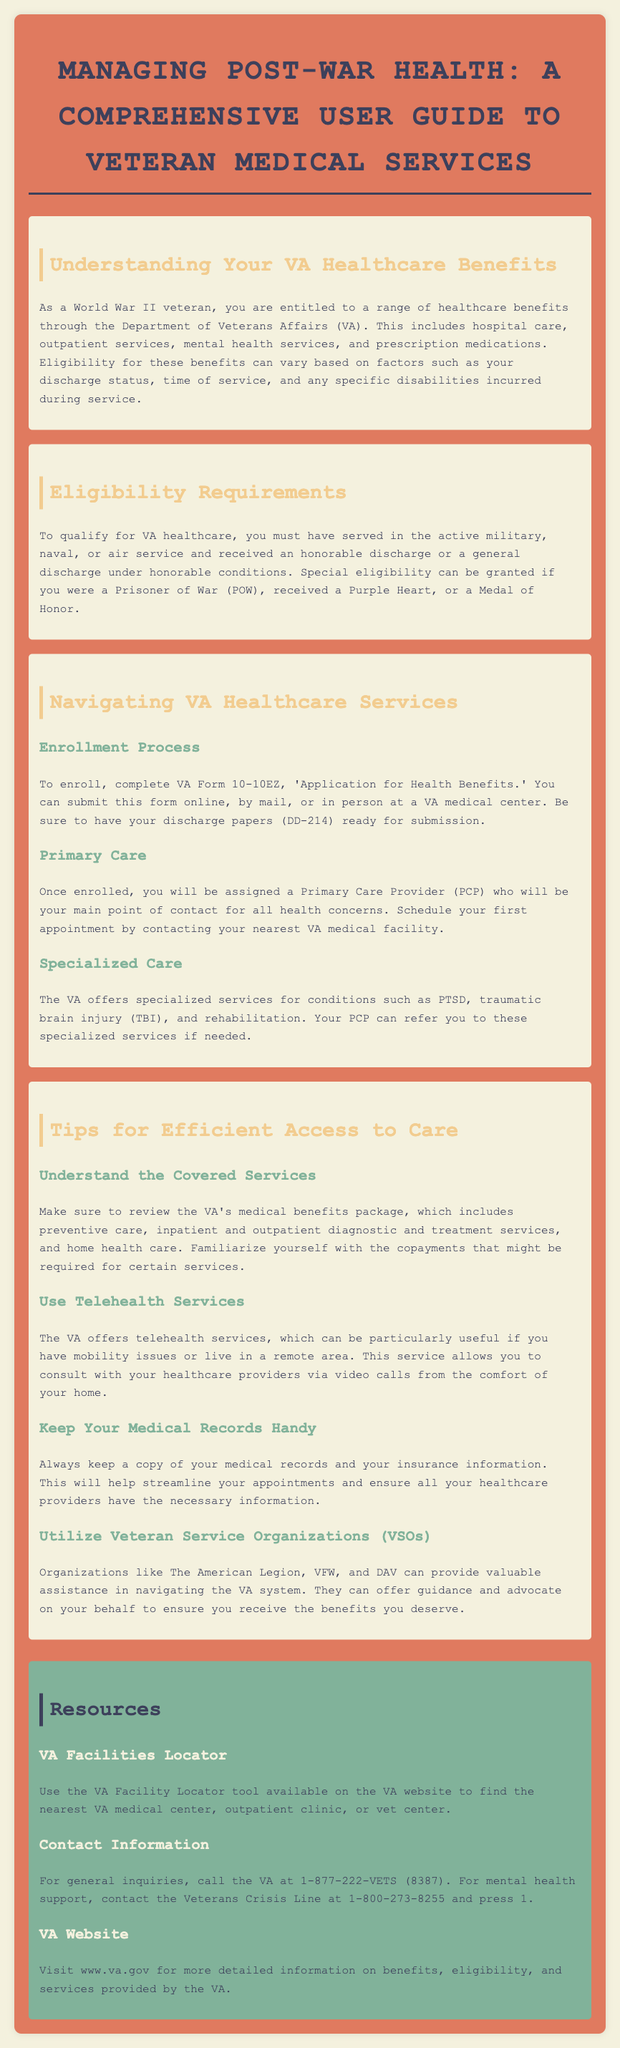What healthcare benefits are available to WWII veterans? The document states that veterans are entitled to hospital care, outpatient services, mental health services, and prescription medications.
Answer: hospital care, outpatient services, mental health services, and prescription medications What form do you need to enroll in VA healthcare? Enrollment requires completing VA Form 10-10EZ, 'Application for Health Benefits.'
Answer: VA Form 10-10EZ What is a requirement for eligibility for VA healthcare? To qualify, veterans must have served in the active military and received an honorable discharge or a general discharge under honorable conditions.
Answer: honorable discharge What can your Primary Care Provider (PCP) refer you to? A PCP can refer you to specialized services for conditions such as PTSD and traumatic brain injury (TBI).
Answer: specialized services for conditions such as PTSD and traumatic brain injury (TBI) What is one tip for accessing VA healthcare efficiently? Familiarize yourself with the copayments that might be required for certain services.
Answer: Familiarize yourself with copayments What service does the VA offer for those with mobility issues? The VA offers telehealth services that allow consultations via video calls.
Answer: telehealth services What organizations can help veterans navigate the VA system? Veteran Service Organizations (VSOs) like The American Legion, VFW, and DAV can assist veterans.
Answer: The American Legion, VFW, and DAV What number can you call for general inquiries to the VA? Veterans can contact the VA at 1-877-222-VETS (8387) for general inquiries.
Answer: 1-877-222-VETS (8387) What is the purpose of the VA Facility Locator tool? The tool is used to find the nearest VA medical center, outpatient clinic, or vet center.
Answer: to find the nearest VA medical center, outpatient clinic, or vet center 